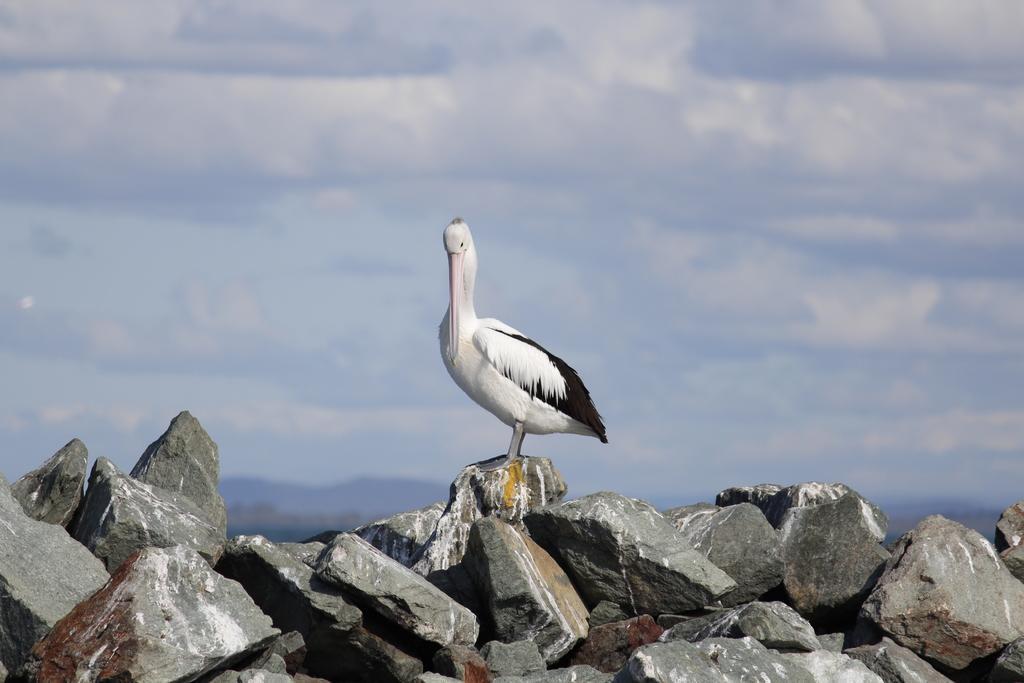Can you describe this image briefly? In this picture there is a crane standing on the stone. In the foreground there are stones. At the back there are mountains. At the top there is sky and there clouds. 